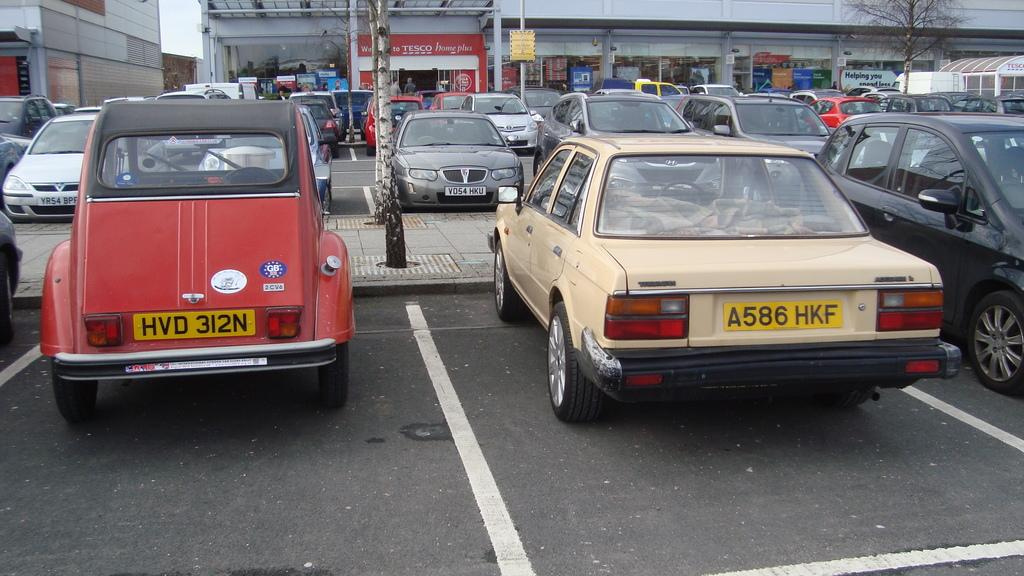What can be seen on the road in the image? There are vehicles parked on the road in the image. What is visible in the background of the image? There are shops, showrooms, and trees in the background of the image. How many quarters can be seen on the back of the vehicles in the image? There are no quarters visible on the vehicles in the image. What is the best way to reach the showrooms in the image? The image does not provide information on the best way to reach the showrooms; it only shows their presence in the background. 